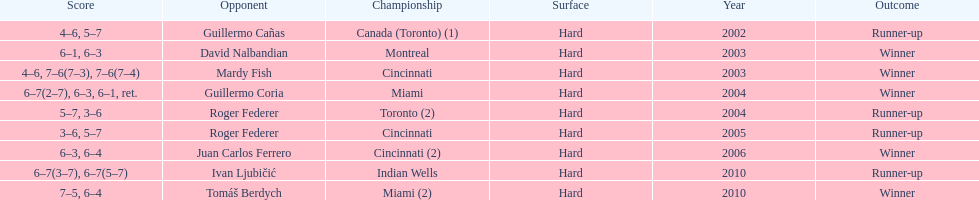How many times has he been runner-up? 4. 